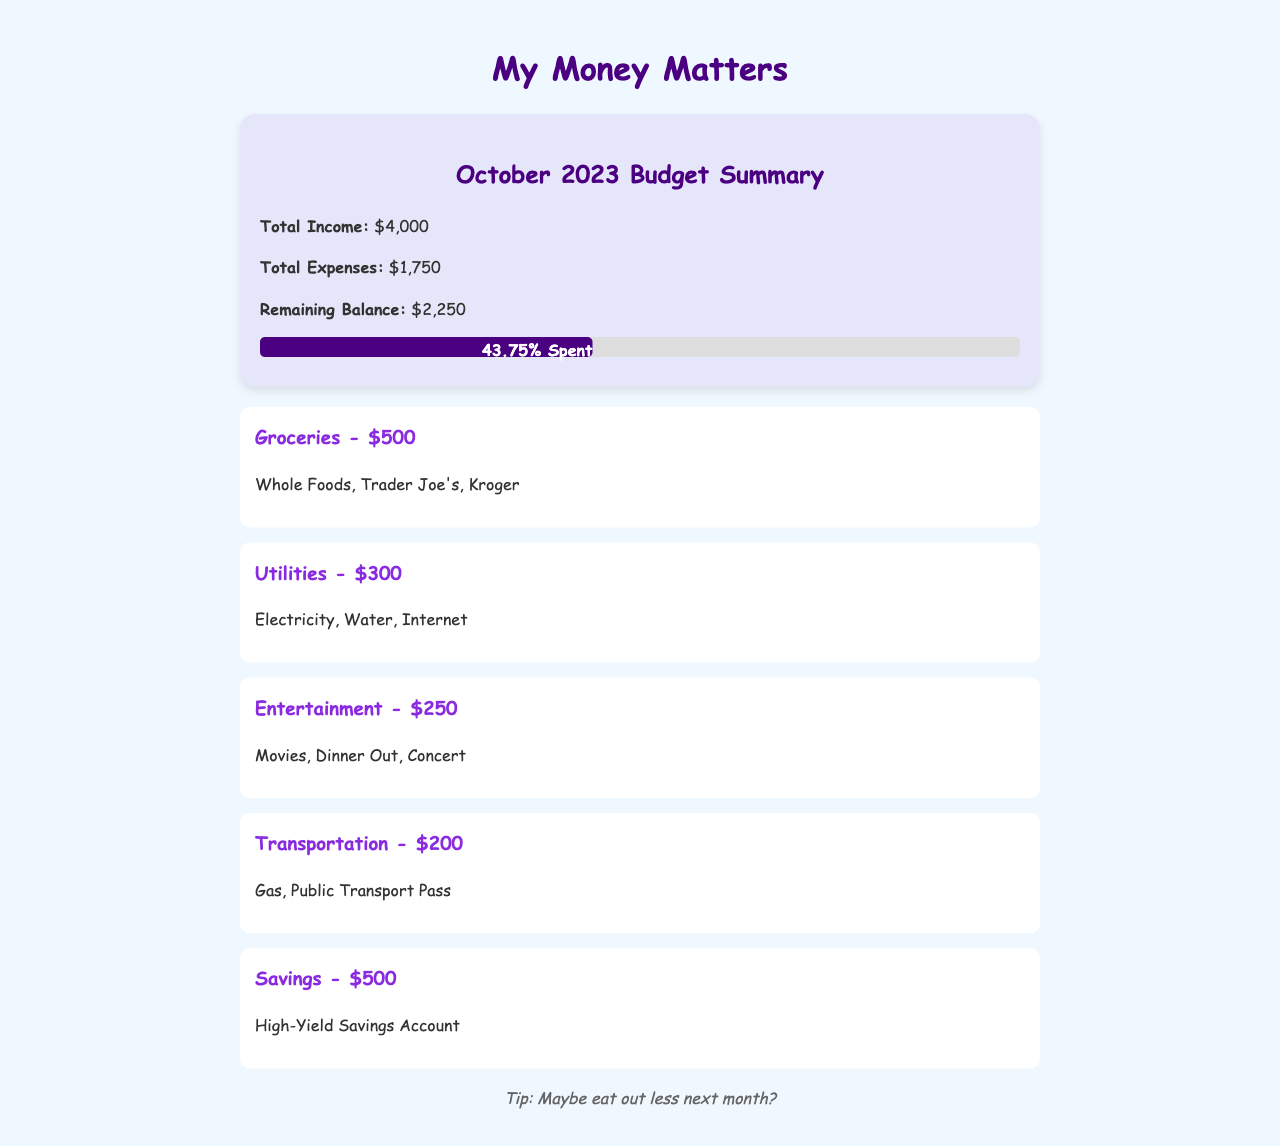What is the total income? The total income is listed clearly in the document as $4,000.
Answer: $4,000 What is the total amount spent? The document shows the total expenses incurred, which is $1,750.
Answer: $1,750 How much is left after expenses? The remaining balance, calculated by subtracting total expenses from total income, is $2,250.
Answer: $2,250 What is the budget for groceries? The document specifies that the budget for groceries is $500.
Answer: $500 Which category has the highest expense? The category with the highest expense is groceries at $500.
Answer: Groceries What percentage of the budget has been spent? The document states that 43.75% of the total budget has been spent.
Answer: 43.75% What type of savings account is mentioned? The document refers to a high-yield savings account.
Answer: High-Yield Savings Account Which category includes movies? The entertainment category includes movies as part of its expenses.
Answer: Entertainment Is there a suggestion for next month? The document includes a note suggesting to potentially eat out less next month.
Answer: Eat out less 